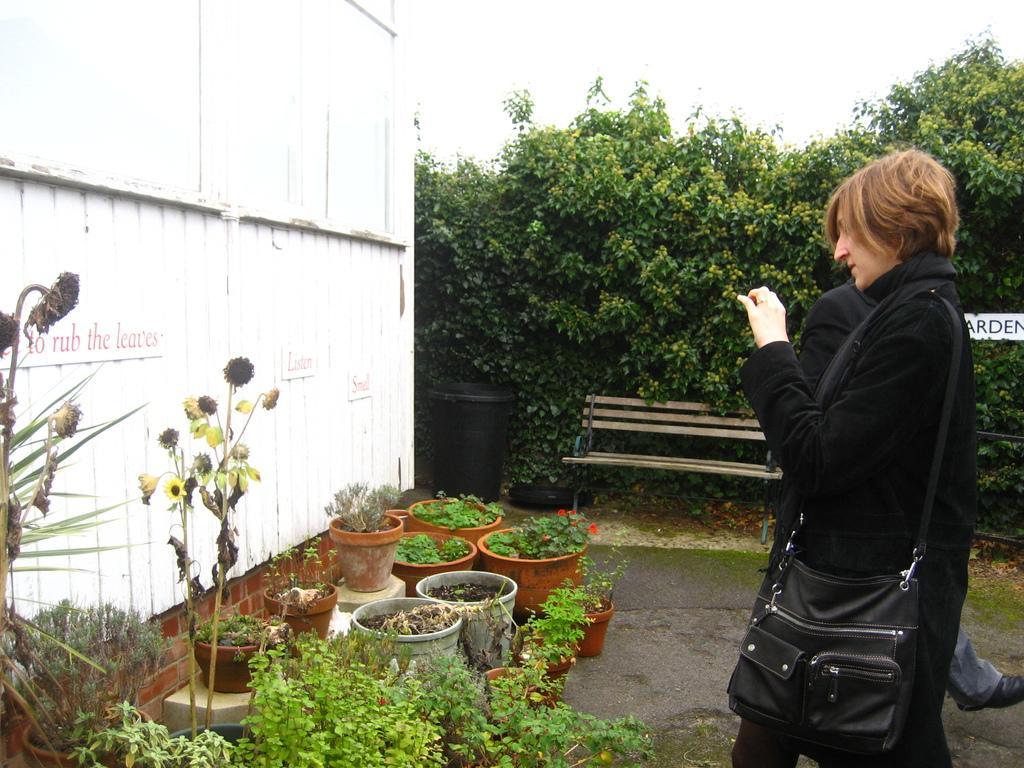Could you give a brief overview of what you see in this image? In the bottom left side of the image there are some plants and wall. In the bottom right side of the image a woman is standing and holding something in her hand. Beside her a person is standing. In the middle of the image there is a dustbin and bench. Behind the bench there are some plants. At the top of the image there is sky. 